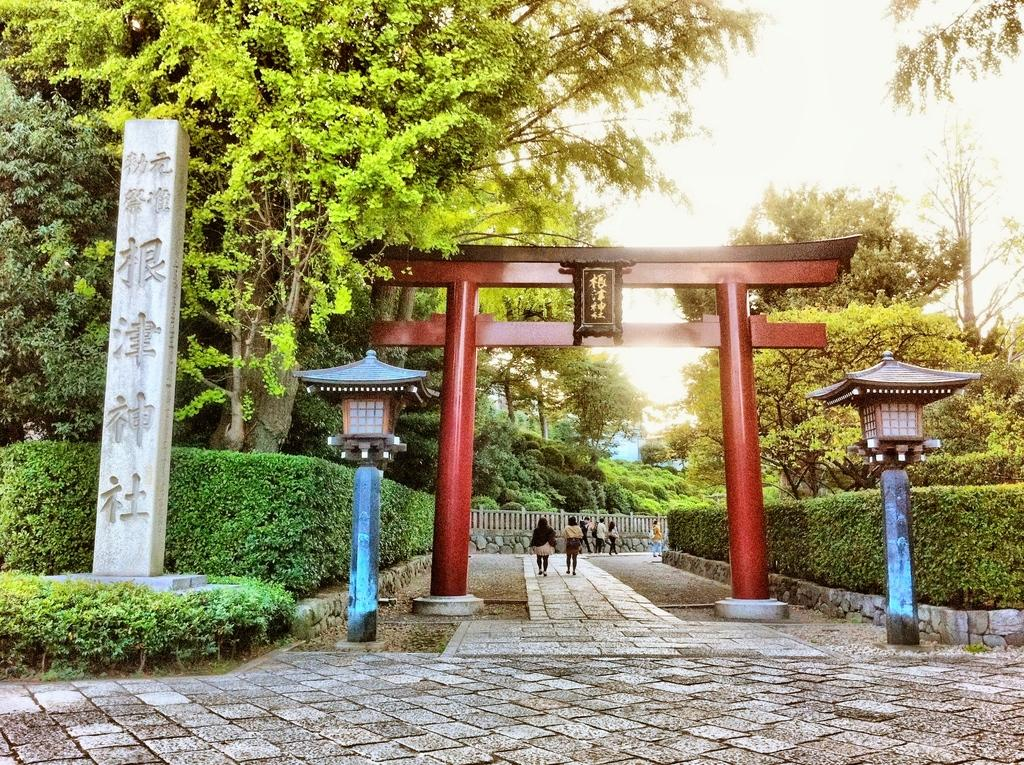What type of vegetation is on the right side of the image? There are trees on the right side of the image. What type of vegetation is on the left side of the image? There are trees on the left side of the image. What objects provide light in the image? There are lamps in the image. What type of cork can be seen on the roof in the image? There is no cork or roof present in the image. 